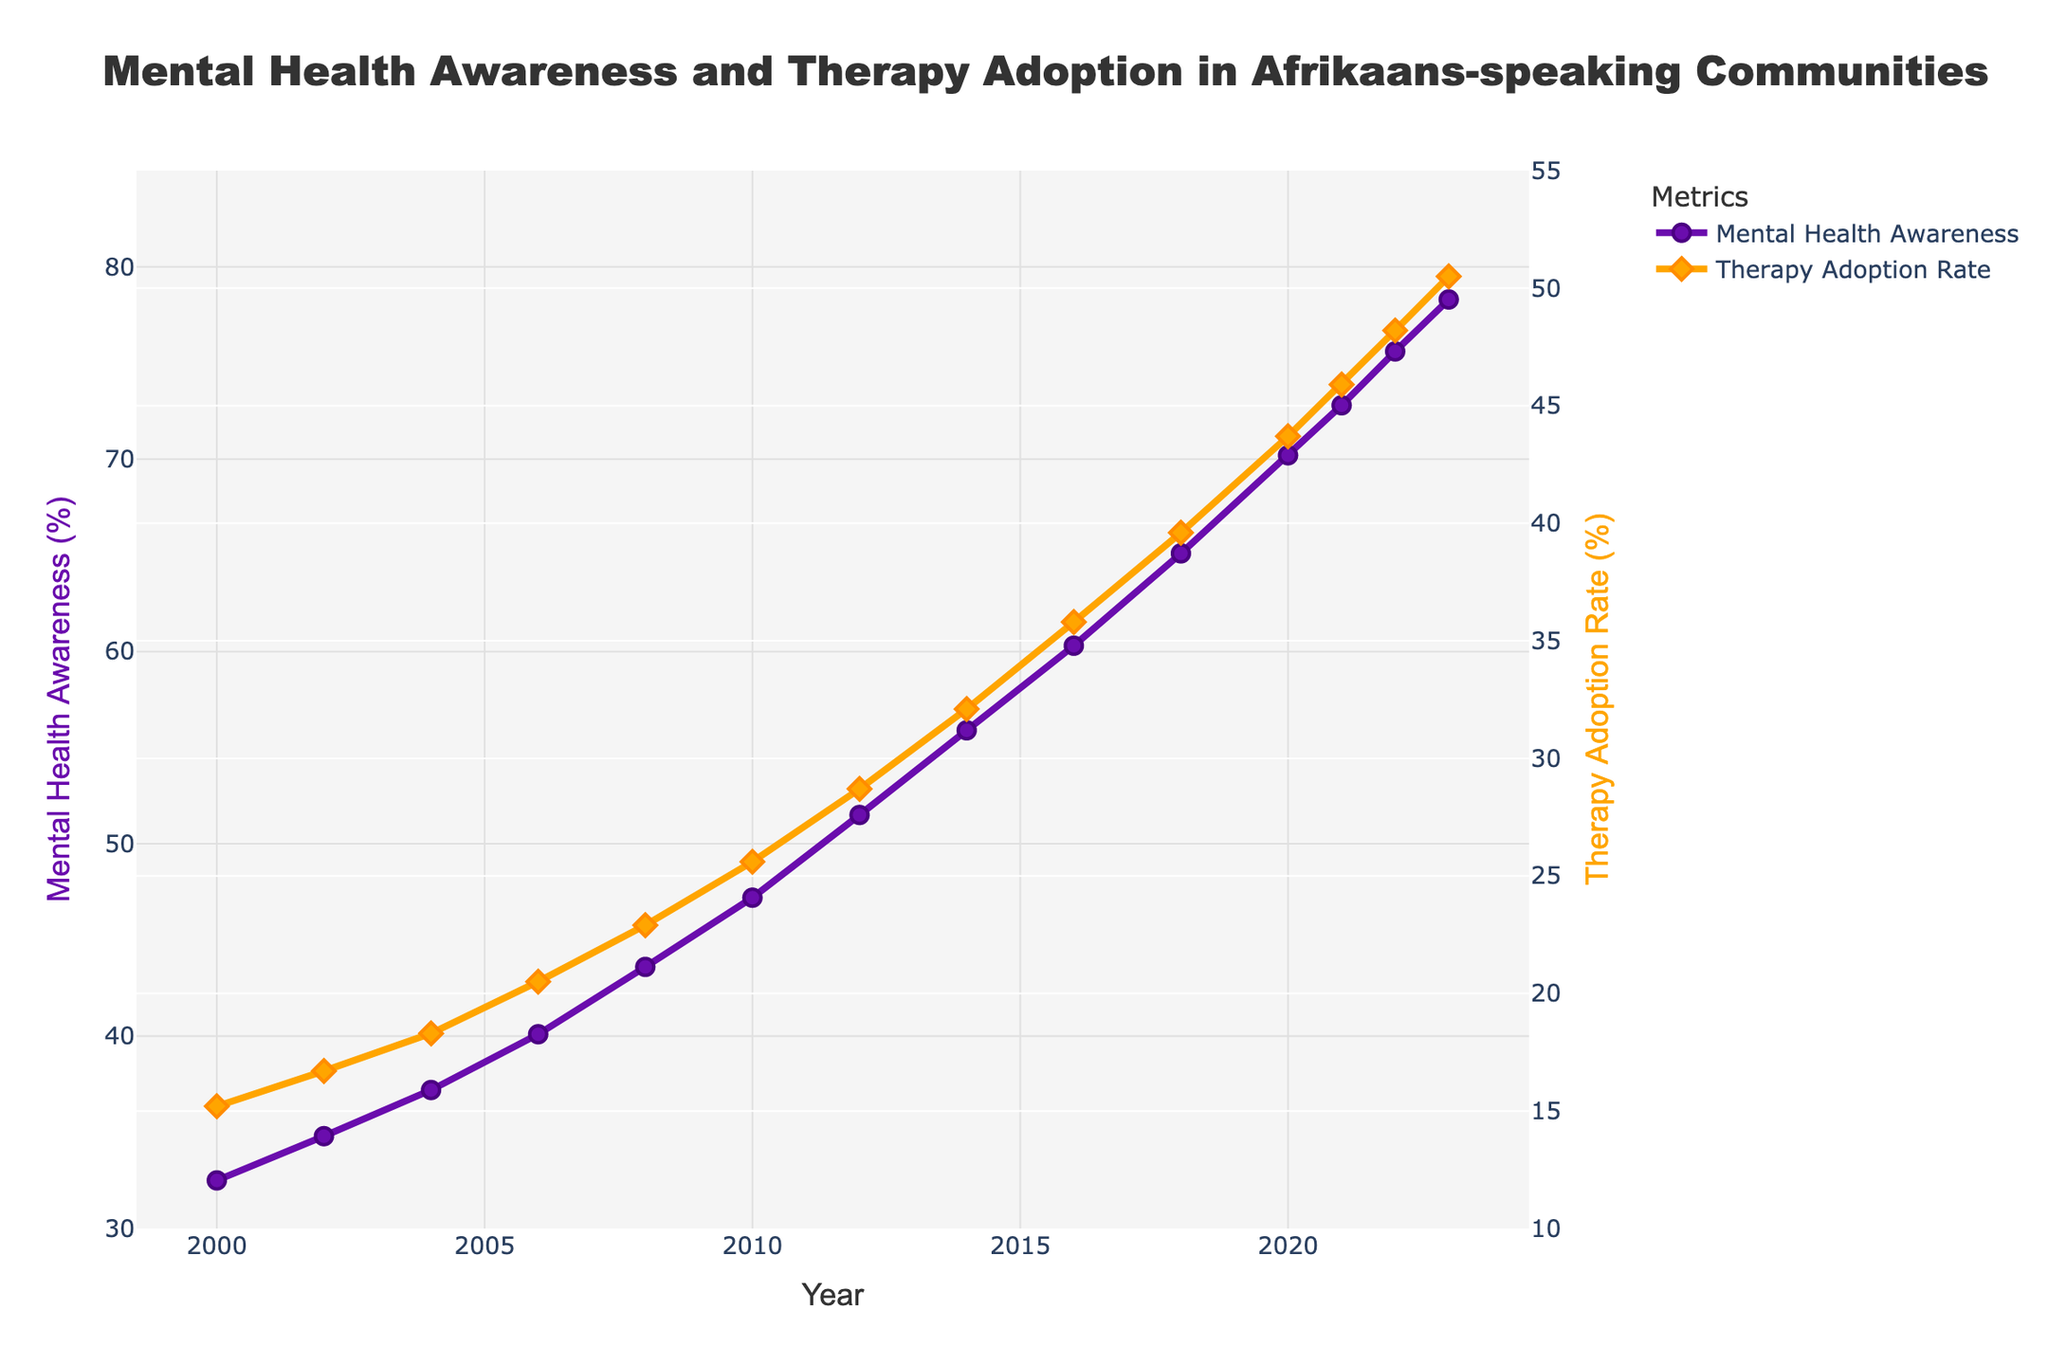1. What was the percentage increase in Mental Health Awareness from 2000 to 2023? The Mental Health Awareness in 2000 was 32.5%, and in 2023 it was 78.3%. The percentage increase can be calculated as (78.3 - 32.5) / 32.5 * 100 = 141%.
Answer: 141% 2. By how many percentage points did Therapy Adoption Rate increase between 2018 and 2023? The Therapy Adoption Rate in 2018 was 39.6%, and in 2023 it was 50.5%. The increase is calculated as 50.5 - 39.6 = 10.9 percentage points.
Answer: 10.9 3. In which year did Therapy Adoption Rate surpass 35%? By looking at the plot, we see that Therapy Adoption Rate surpassed 35% in the year 2016 with a rate of 35.8%.
Answer: 2016 4. What is the difference between Mental Health Awareness and Therapy Adoption Rate in 2023? In 2023, Mental Health Awareness was 78.3%, and Therapy Adoption Rate was 50.5%. The difference is calculated as 78.3 - 50.5 = 27.8%.
Answer: 27.8 5. Which metric showed a higher percentage increase from 2010 to 2020, Mental Health Awareness or Therapy Adoption Rate? From 2010 to 2020, Mental Health Awareness increased from 47.2% to 70.2%, a percentage increase of (70.2 - 47.2) / 47.2 * 100 = 48.7%. Therapy Adoption Rate increased from 25.6% to 43.7%, a percentage increase of (43.7 - 25.6) / 25.6 * 100 = 70.7%. Therapy Adoption Rate showed a higher percentage increase.
Answer: Therapy Adoption Rate 6. How many years did it take for the Therapy Adoption Rate to increase by at least 10 percentage points from its 2000 value? In 2000, the Therapy Adoption Rate was 15.2%. To see an increase of at least 10 percentage points, it must reach 25.2%. This occurred in 2010, which is 10 years after 2000.
Answer: 10 7. What year saw the sharpest increase in Mental Health Awareness? Examining the year-over-year changes in Mental Health Awareness, the sharpest increase appears to be from 2016 to 2018, increasing from 60.3% to 65.1%, a change of 4.8 percentage points.
Answer: 2018 8. Between which consecutive years did Therapy Adoption Rate experience its largest increase? Looking at the plot, the largest year-over-year increase in Therapy Adoption Rate appears between 2018 (39.6%) and 2020 (43.7%), a 4.1 percentage point increase.
Answer: 2020 9. What was the average Therapy Adoption Rate from 2000 to 2023? Sum the Therapy Adoption Rates for each year (15.2 + 16.7 + 18.3 + 20.5 + 22.9 + 25.6 + 28.7 + 32.1 + 35.8 + 39.6 + 43.7 + 45.9 + 48.2 + 50.5) = 443.7, and divide by the number of years (14) to get the average: 443.7 / 14 ≈ 31.7%.
Answer: 31.7% 10. What can be inferred visually about the general trend of Mental Health Awareness and Therapy Adoption Rate from 2000 to 2023? Both Mental Health Awareness and Therapy Adoption Rate show an increasing trend from 2000 to 2023, with Mental Health Awareness consistently higher than Therapy Adoption Rate across all years shown in the graph.
Answer: Increasing trend 